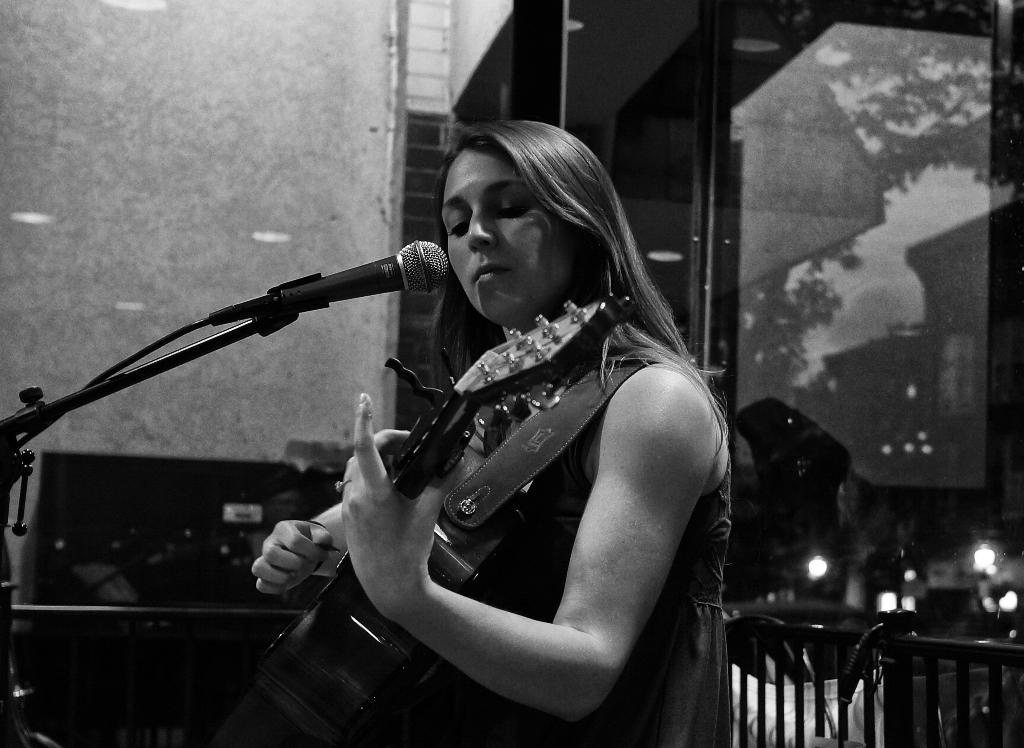Who is the main subject in the image? There is a woman in the image. What is the woman doing in the image? The woman is playing a guitar. What object is in front of the woman? There is a microphone in front of the woman. What is the purpose of the stand in front of the woman? There is a stand in front of the woman, which might be used to hold sheet music or lyrics. What can be seen in the background of the image? There is a wall in the background of the image. How does the woman handle the loss of her credit card in the image? There is no indication of a credit card or any loss in the image; it features a woman playing a guitar with a microphone and stand in front of her. 